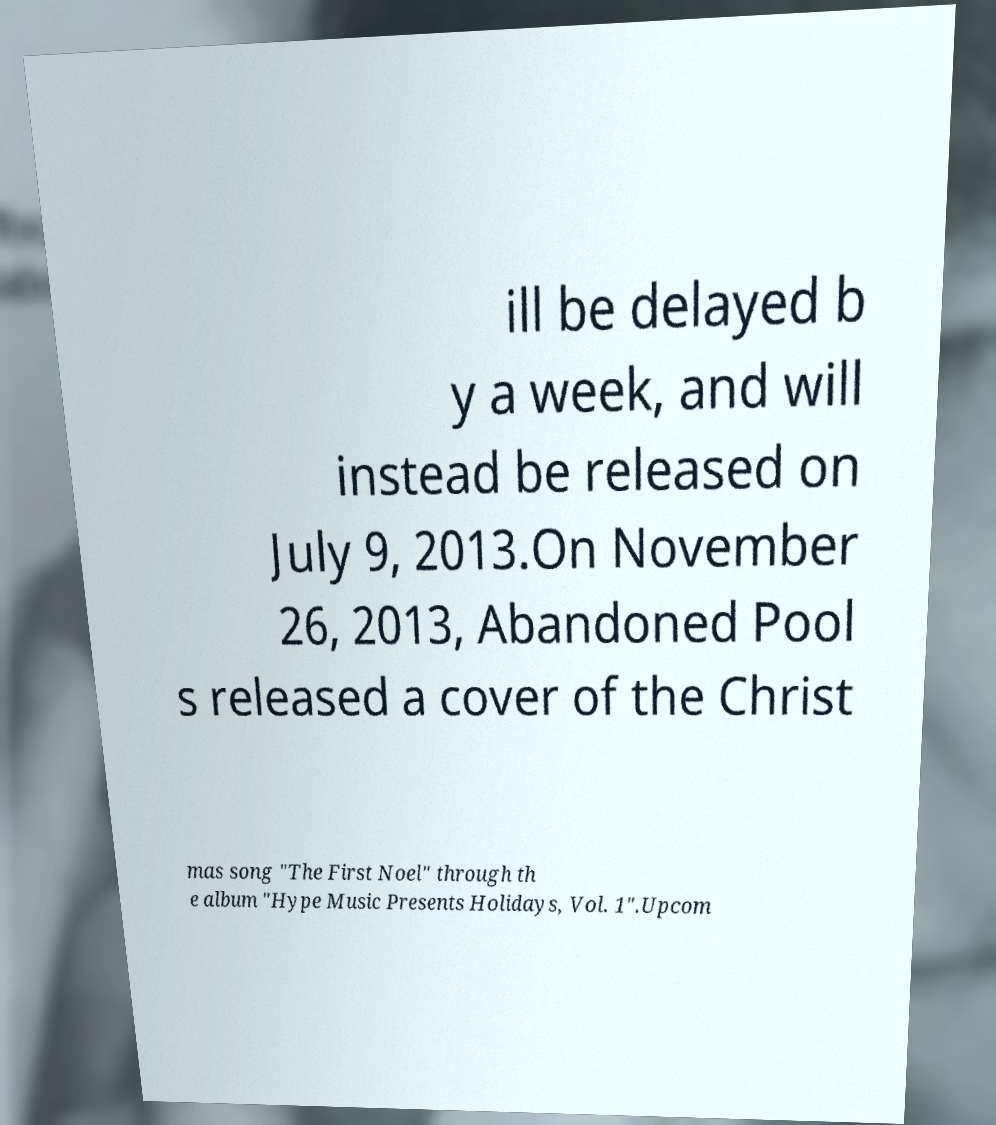For documentation purposes, I need the text within this image transcribed. Could you provide that? ill be delayed b y a week, and will instead be released on July 9, 2013.On November 26, 2013, Abandoned Pool s released a cover of the Christ mas song "The First Noel" through th e album "Hype Music Presents Holidays, Vol. 1".Upcom 